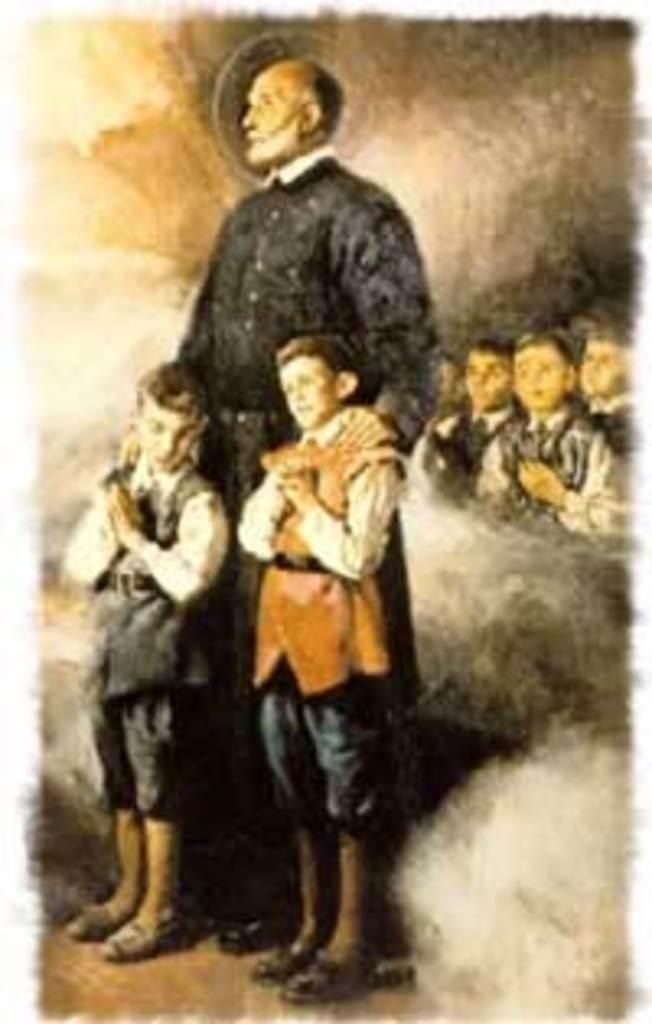How many people are in the foreground of the image? There are two kids and a man standing in the foreground of the image. Where are the kids located in the image? The kids are standing on the right side of the image. What can be observed around the kids on the right side of the image? There is smoke around the kids on the right side of the image. What type of copy is being made by the kids on the left side of the image? There are no kids on the left side of the image, and no copying activity is depicted. 